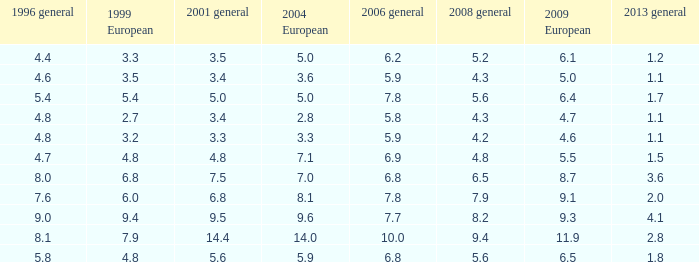What is the lowest value for 2004 European when 1999 European is 3.3 and less than 4.4 in 1996 general? None. 